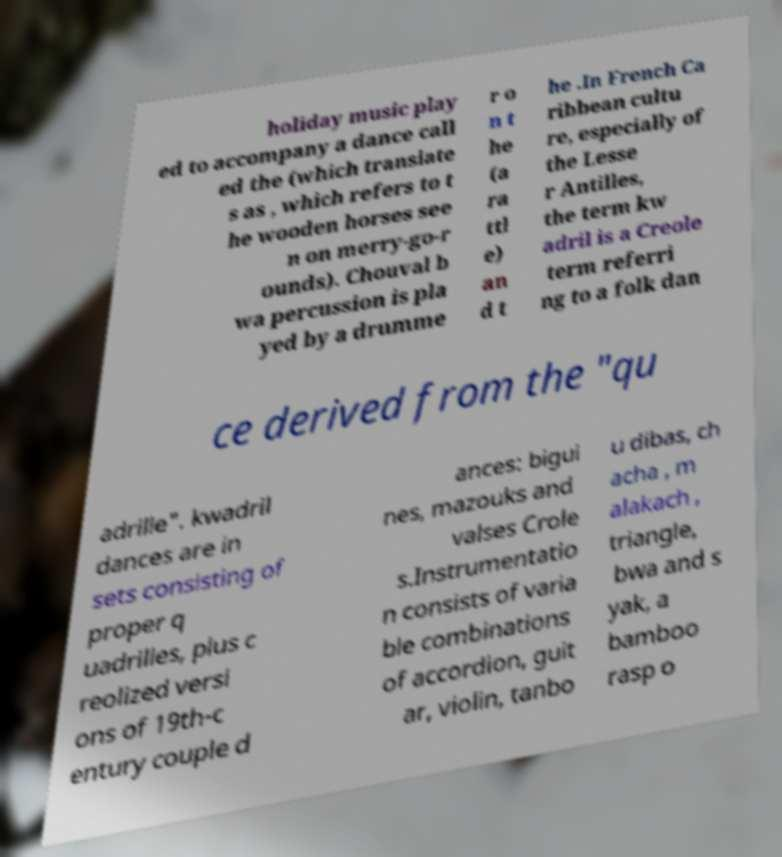For documentation purposes, I need the text within this image transcribed. Could you provide that? holiday music play ed to accompany a dance call ed the (which translate s as , which refers to t he wooden horses see n on merry-go-r ounds). Chouval b wa percussion is pla yed by a drumme r o n t he (a ra ttl e) an d t he .In French Ca ribbean cultu re, especially of the Lesse r Antilles, the term kw adril is a Creole term referri ng to a folk dan ce derived from the "qu adrille". kwadril dances are in sets consisting of proper q uadrilles, plus c reolized versi ons of 19th-c entury couple d ances: bigui nes, mazouks and valses Crole s.Instrumentatio n consists of varia ble combinations of accordion, guit ar, violin, tanbo u dibas, ch acha , m alakach , triangle, bwa and s yak, a bamboo rasp o 